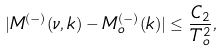Convert formula to latex. <formula><loc_0><loc_0><loc_500><loc_500>| M ^ { ( - ) } ( \nu , k ) - M ^ { ( - ) } _ { o } ( k ) | \leq \frac { C _ { 2 } } { T ^ { 2 } _ { o } } ,</formula> 